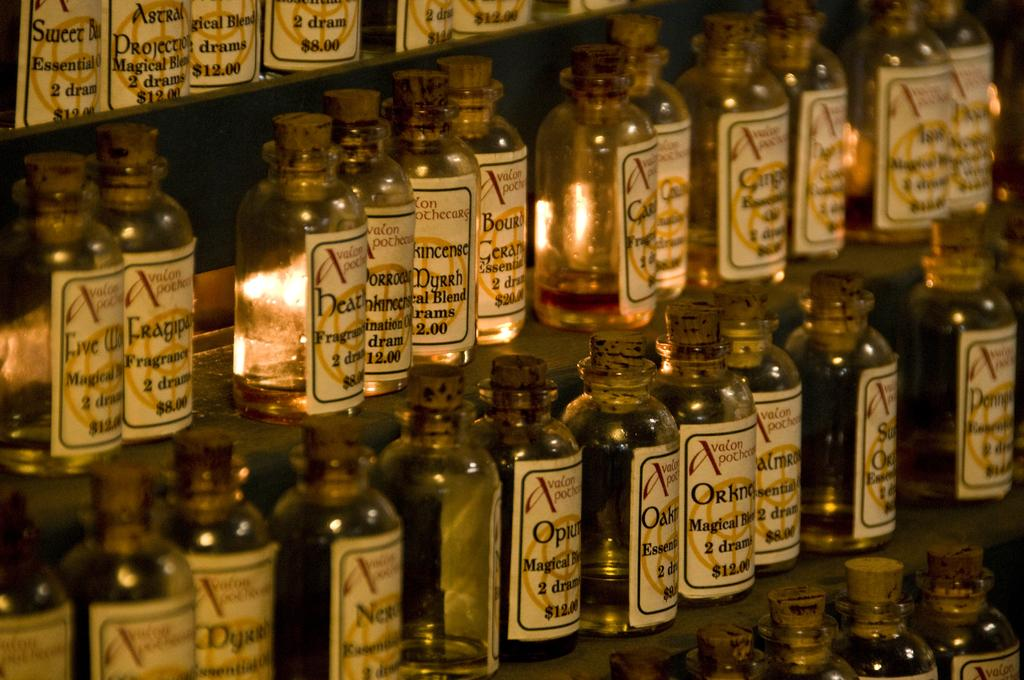<image>
Summarize the visual content of the image. Many glass bottles but the first bottle on the second shelf is magical. 